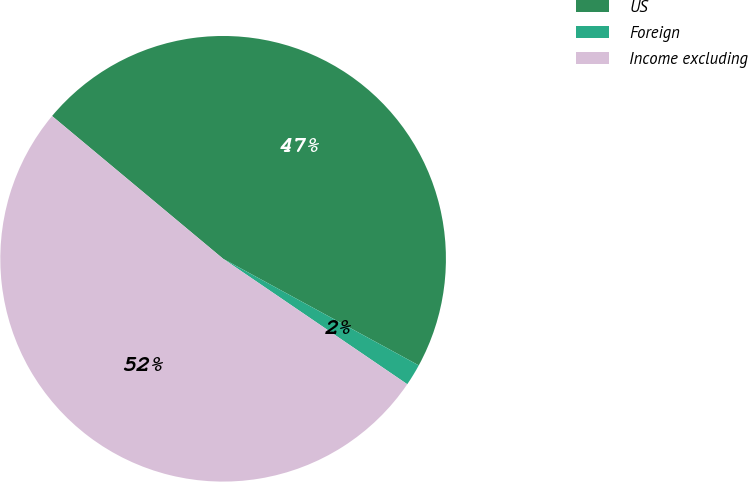<chart> <loc_0><loc_0><loc_500><loc_500><pie_chart><fcel>US<fcel>Foreign<fcel>Income excluding<nl><fcel>46.87%<fcel>1.58%<fcel>51.55%<nl></chart> 